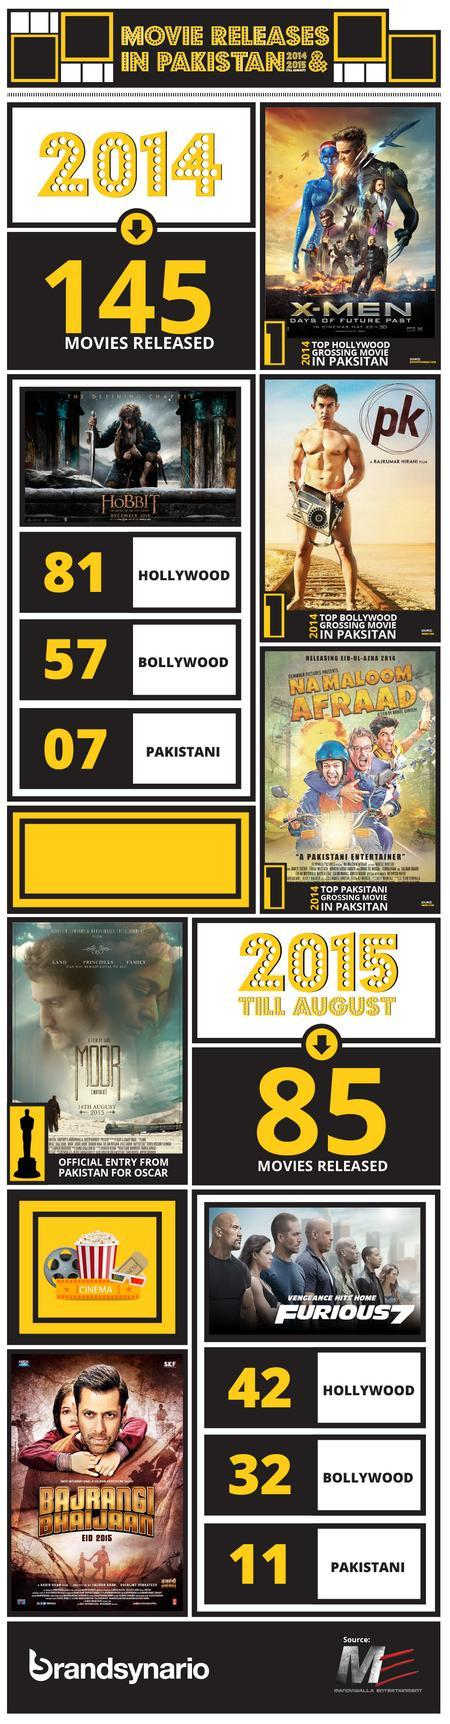What is the total number of movies released in the year 2014 and 2015, taken together?
Answer the question with a short phrase. 230 How many movie names mentioned in this infographic? 7 How many Hollywood movies released in the year 2014 and 2015, taken together? 123 How many Bollywood movies released in the year 2014 and 2015, taken together? 89 How many Pakistani movies released in the year 2014 and 2015, taken together? 18 